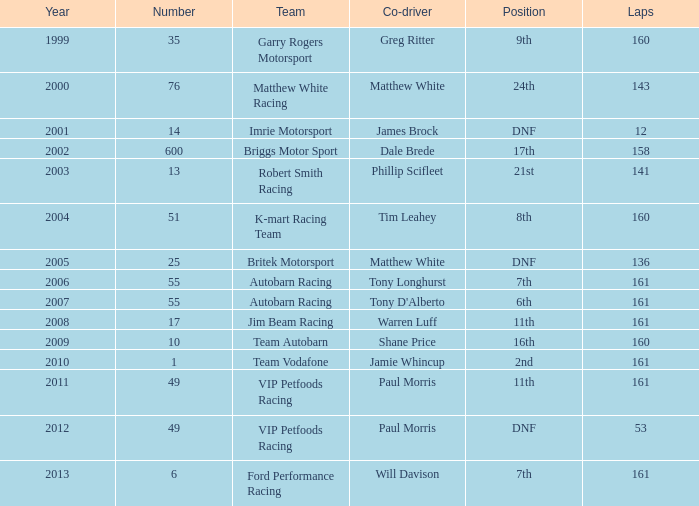Who was the co-driver for the team with more than 160 laps and the number 6 after 2010? Will Davison. 